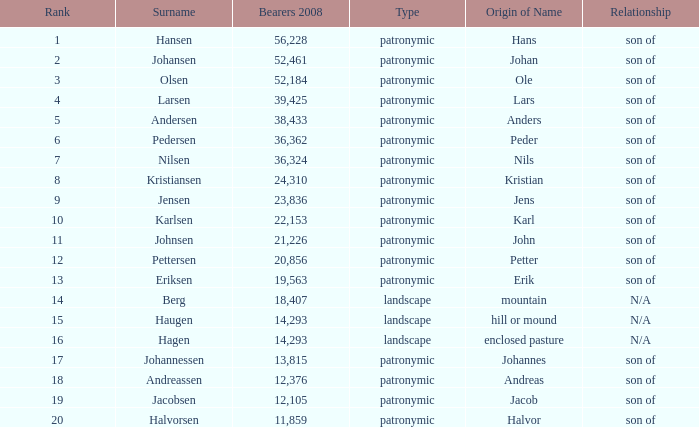What is Etymology, when Rank is 14? Mountain. 